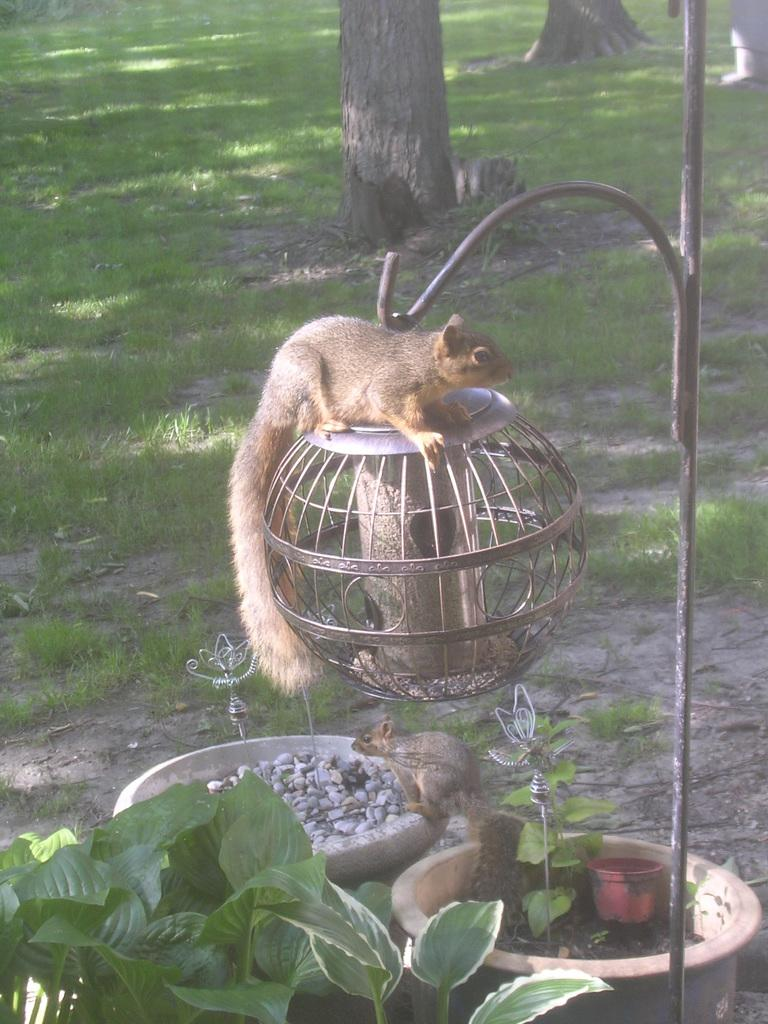What is located in the foreground of the image? In the foreground of the image, there are plants, pots, squirrels, and a bird feeding station. What type of containers are present in the image? There are pots in the foreground of the image. What animals can be seen in the image? Squirrels can be seen in the foreground of the image. What is the purpose of the bird feeding station? The bird feeding station is likely meant to attract and feed birds. What can be seen at the top of the image? Tree trunks and grassland are visible at the top of the image. What type of metal is the police officer using to attack the squirrels in the image? There is no police officer or metal object present in the image, and therefore no such attack can be observed. 